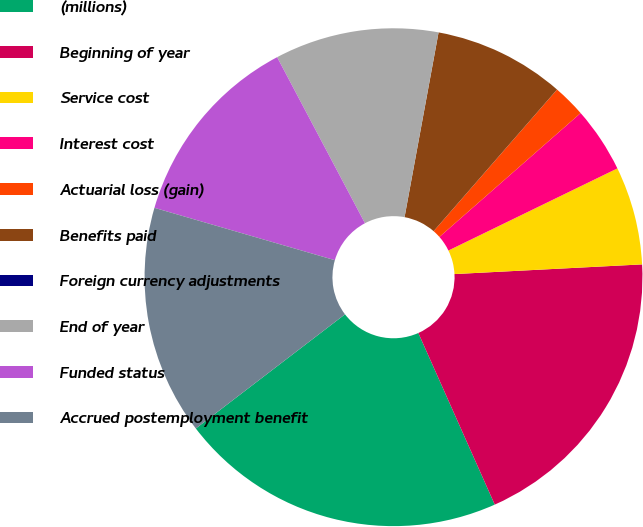Convert chart. <chart><loc_0><loc_0><loc_500><loc_500><pie_chart><fcel>(millions)<fcel>Beginning of year<fcel>Service cost<fcel>Interest cost<fcel>Actuarial loss (gain)<fcel>Benefits paid<fcel>Foreign currency adjustments<fcel>End of year<fcel>Funded status<fcel>Accrued postemployment benefit<nl><fcel>21.27%<fcel>19.15%<fcel>6.38%<fcel>4.26%<fcel>2.13%<fcel>8.51%<fcel>0.0%<fcel>10.64%<fcel>12.76%<fcel>14.89%<nl></chart> 